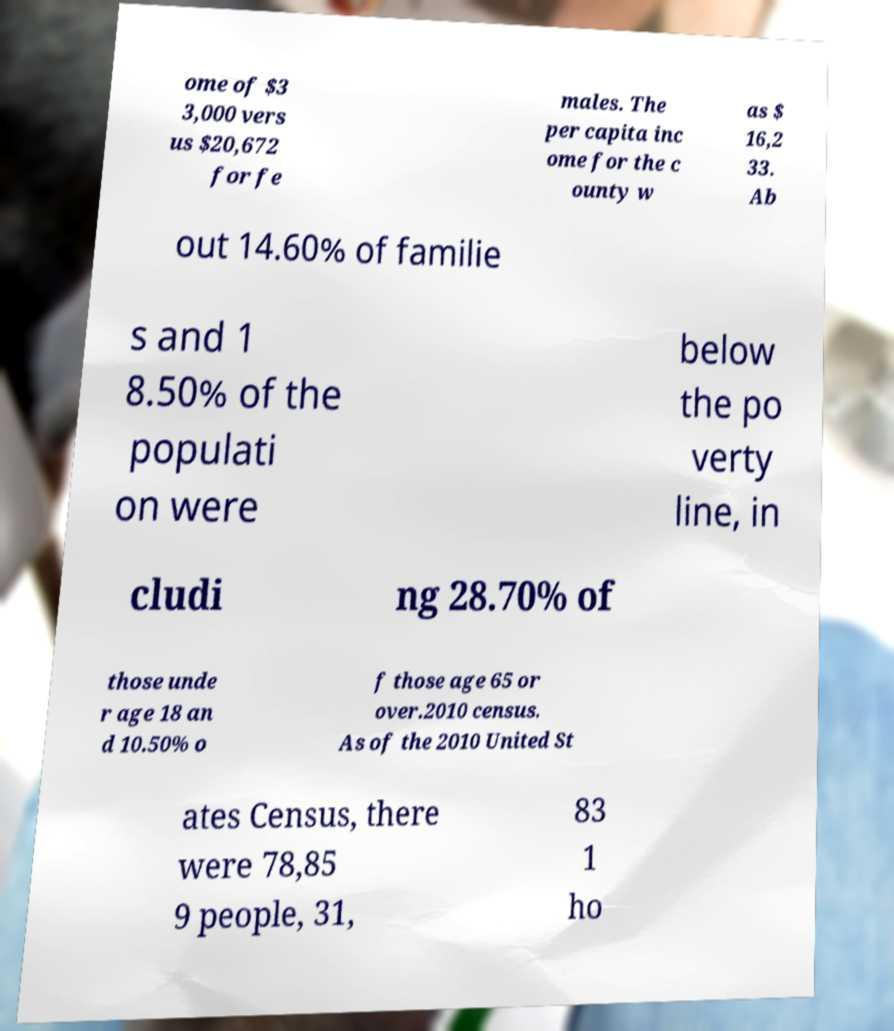For documentation purposes, I need the text within this image transcribed. Could you provide that? ome of $3 3,000 vers us $20,672 for fe males. The per capita inc ome for the c ounty w as $ 16,2 33. Ab out 14.60% of familie s and 1 8.50% of the populati on were below the po verty line, in cludi ng 28.70% of those unde r age 18 an d 10.50% o f those age 65 or over.2010 census. As of the 2010 United St ates Census, there were 78,85 9 people, 31, 83 1 ho 